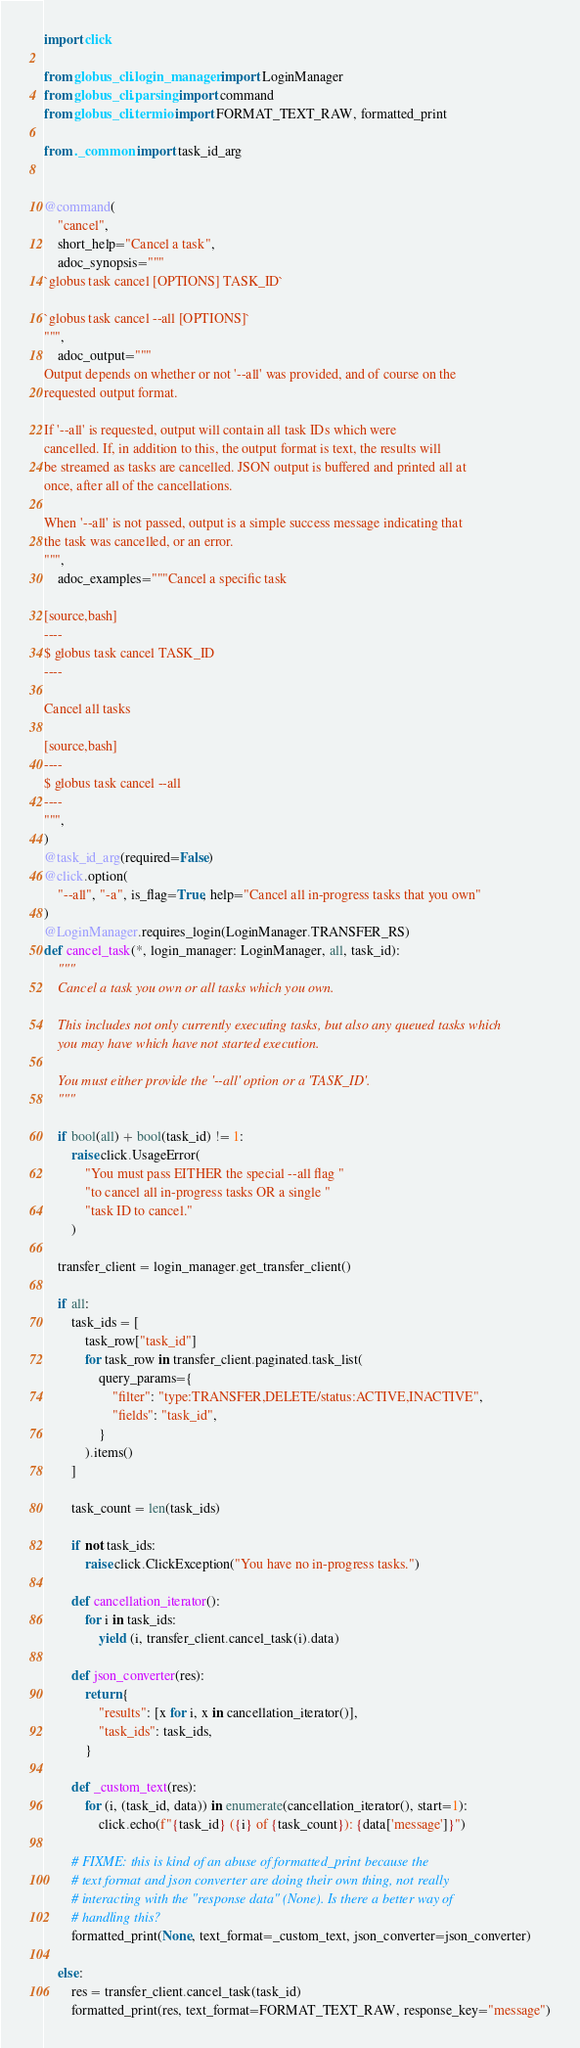<code> <loc_0><loc_0><loc_500><loc_500><_Python_>import click

from globus_cli.login_manager import LoginManager
from globus_cli.parsing import command
from globus_cli.termio import FORMAT_TEXT_RAW, formatted_print

from ._common import task_id_arg


@command(
    "cancel",
    short_help="Cancel a task",
    adoc_synopsis="""
`globus task cancel [OPTIONS] TASK_ID`

`globus task cancel --all [OPTIONS]`
""",
    adoc_output="""
Output depends on whether or not '--all' was provided, and of course on the
requested output format.

If '--all' is requested, output will contain all task IDs which were
cancelled. If, in addition to this, the output format is text, the results will
be streamed as tasks are cancelled. JSON output is buffered and printed all at
once, after all of the cancellations.

When '--all' is not passed, output is a simple success message indicating that
the task was cancelled, or an error.
""",
    adoc_examples="""Cancel a specific task

[source,bash]
----
$ globus task cancel TASK_ID
----

Cancel all tasks

[source,bash]
----
$ globus task cancel --all
----
""",
)
@task_id_arg(required=False)
@click.option(
    "--all", "-a", is_flag=True, help="Cancel all in-progress tasks that you own"
)
@LoginManager.requires_login(LoginManager.TRANSFER_RS)
def cancel_task(*, login_manager: LoginManager, all, task_id):
    """
    Cancel a task you own or all tasks which you own.

    This includes not only currently executing tasks, but also any queued tasks which
    you may have which have not started execution.

    You must either provide the '--all' option or a 'TASK_ID'.
    """

    if bool(all) + bool(task_id) != 1:
        raise click.UsageError(
            "You must pass EITHER the special --all flag "
            "to cancel all in-progress tasks OR a single "
            "task ID to cancel."
        )

    transfer_client = login_manager.get_transfer_client()

    if all:
        task_ids = [
            task_row["task_id"]
            for task_row in transfer_client.paginated.task_list(
                query_params={
                    "filter": "type:TRANSFER,DELETE/status:ACTIVE,INACTIVE",
                    "fields": "task_id",
                }
            ).items()
        ]

        task_count = len(task_ids)

        if not task_ids:
            raise click.ClickException("You have no in-progress tasks.")

        def cancellation_iterator():
            for i in task_ids:
                yield (i, transfer_client.cancel_task(i).data)

        def json_converter(res):
            return {
                "results": [x for i, x in cancellation_iterator()],
                "task_ids": task_ids,
            }

        def _custom_text(res):
            for (i, (task_id, data)) in enumerate(cancellation_iterator(), start=1):
                click.echo(f"{task_id} ({i} of {task_count}): {data['message']}")

        # FIXME: this is kind of an abuse of formatted_print because the
        # text format and json converter are doing their own thing, not really
        # interacting with the "response data" (None). Is there a better way of
        # handling this?
        formatted_print(None, text_format=_custom_text, json_converter=json_converter)

    else:
        res = transfer_client.cancel_task(task_id)
        formatted_print(res, text_format=FORMAT_TEXT_RAW, response_key="message")
</code> 